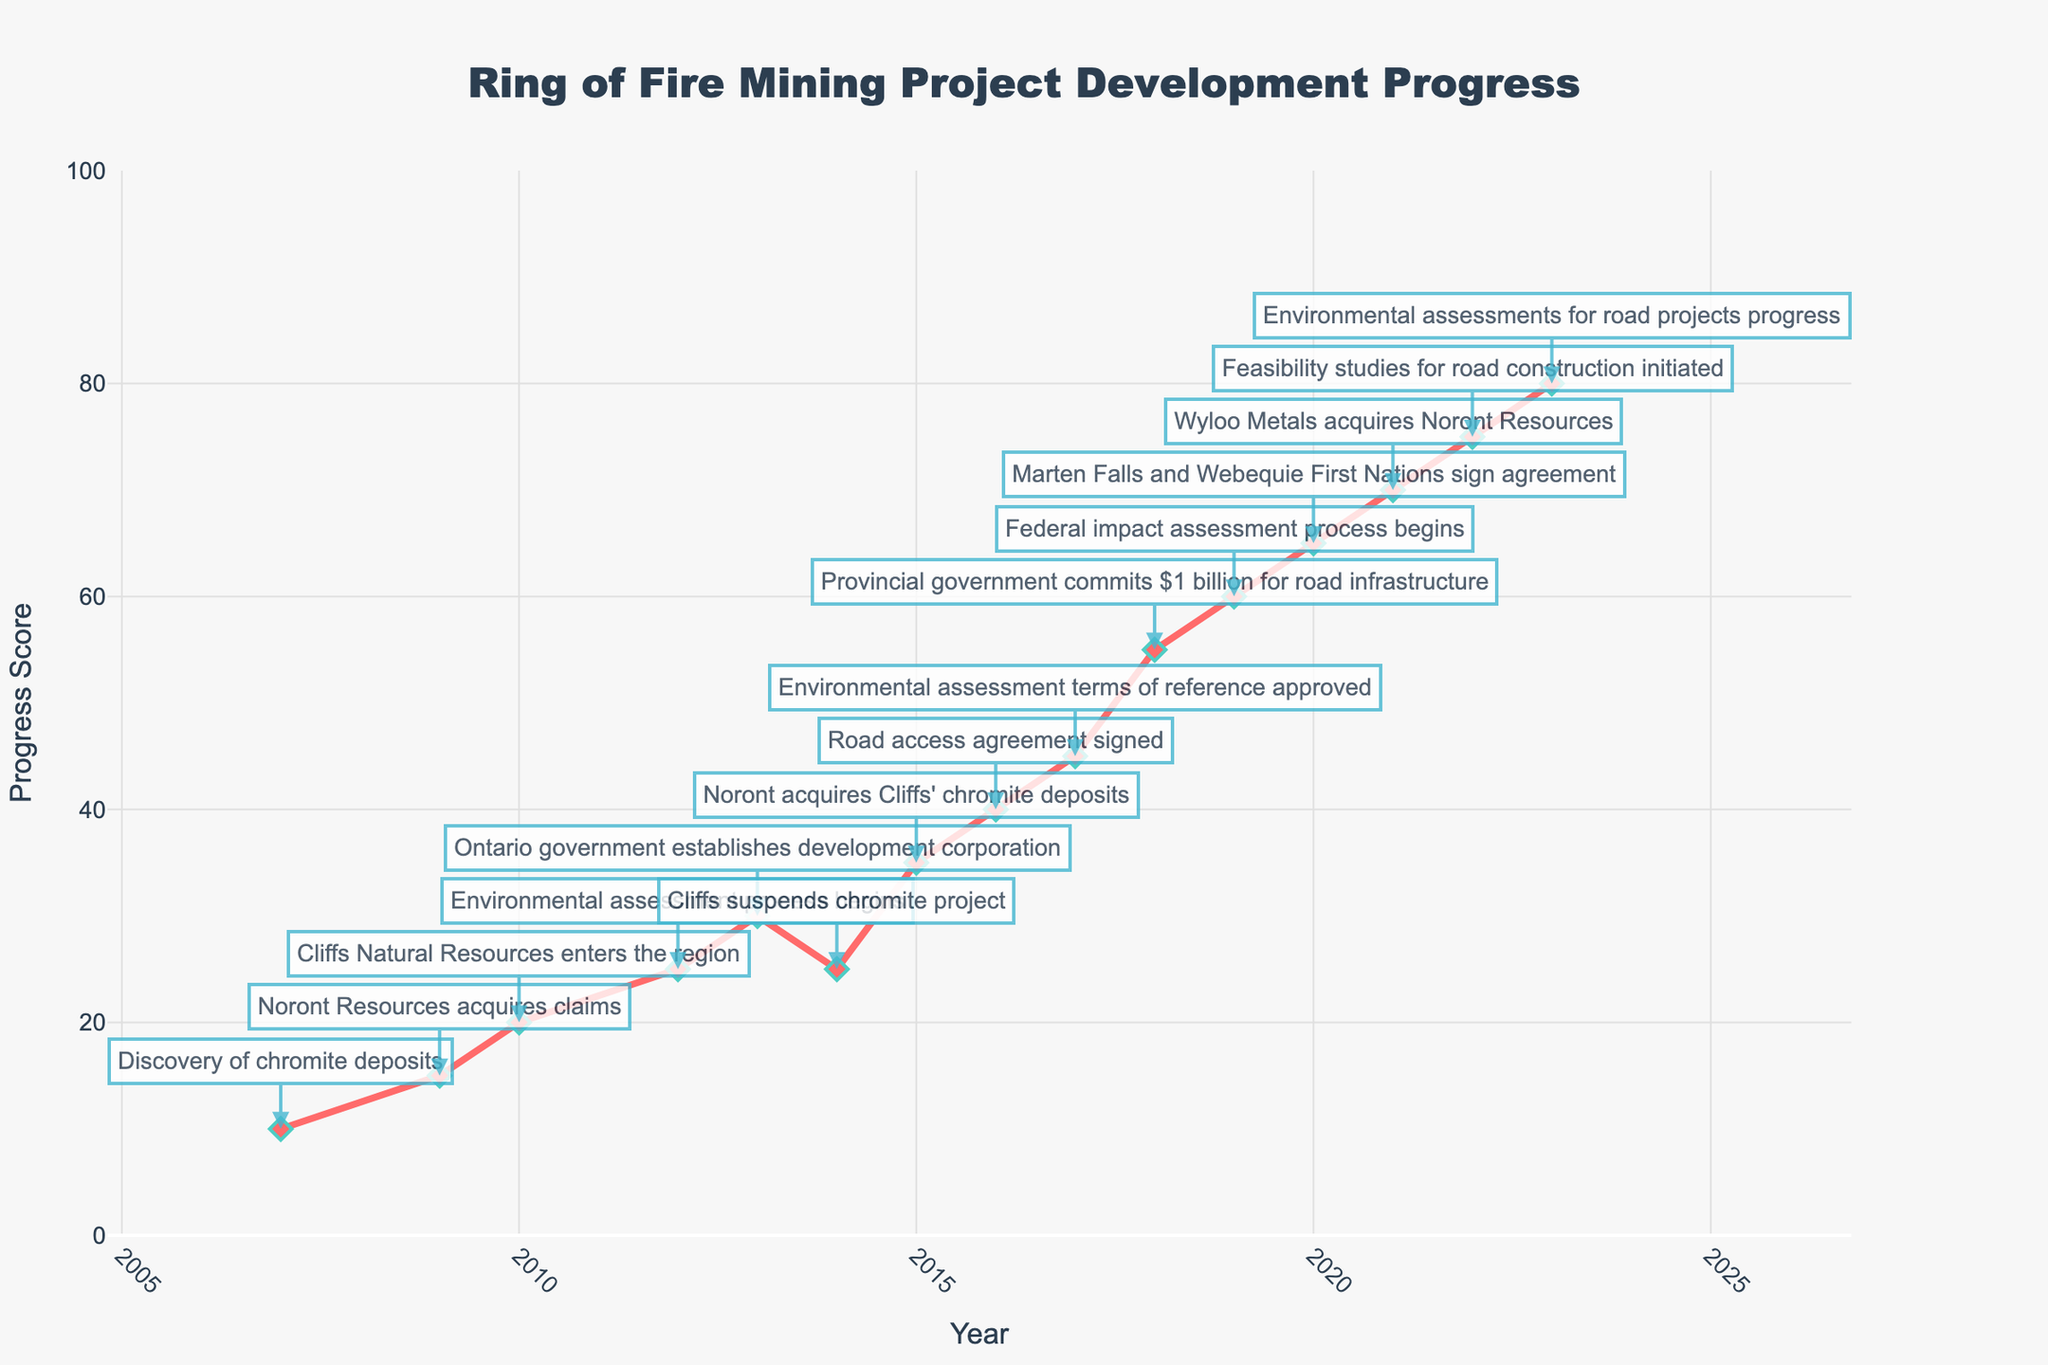What's the milestone in 2017? Look for the annotation on the year 2017 in the chart and read the milestone text.
Answer: Environmental assessment terms of reference approved Which year saw the biggest drop in the progress score? Identify the years and compare the change in progress scores. The biggest drop occurred between 2013 and 2014, from 30 to 25.
Answer: 2014 How many milestones were reached by 2015? Count the number of annotations from 2007 up to and including 2015. They are: Discovery of chromite deposits, Noront Resources acquires claims, Cliffs Natural Resources enters the region, Environmental assessment process begins, Ontario government establishes development corporation, Cliffs suspends chromite project, and Noront acquires Cliffs' chromite deposits.
Answer: 7 What is the progress score difference between 2010 and 2020? Subtract the progress score in 2010 from that in 2020. The progress score in 2010 is 20, and in 2020, it is 65. So, the difference is 65 - 20.
Answer: 45 Which year had a progress milestone right after a funding commitment from the provincial government? Identify the year of the funding commitment first, which is 2018. The next milestone after 2018 is in 2019.
Answer: 2019 What major acquisition happened in 2021? Look for the annotation on the year 2021 in the chart and read the milestone text.
Answer: Wyloo Metals acquires Noront Resources How does the progress score in 2019 compare to 2016? Compare the progress scores of the years 2019 and 2016. The progress score in 2016 is 40, and in 2019, it is 60.
Answer: Higher in 2019 Between 2007 and 2023, what is the average annual progress score change? Find the total change in progress score from 2007 (10) to 2023 (80) and divide by the number of years (2023-2007 = 16 years). The total change is 80 - 10 = 70. Average annual change = 70 / 16.
Answer: 4.375 What is significant about the milestone in 2013? Look for the annotation on the year 2013 and read the milestone text. It indicates that the Ontario government established the development corporation, a significant governmental intervention.
Answer: Ontario government establishes development corporation 